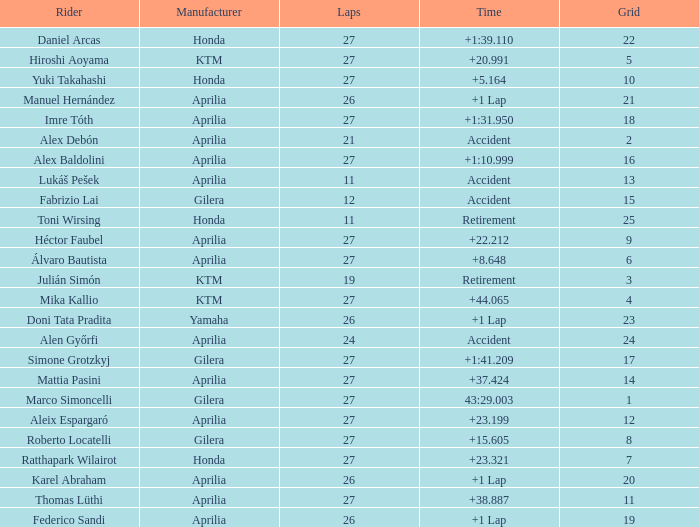Which Manufacturer has a Time of accident and a Grid greater than 15? Aprilia. 